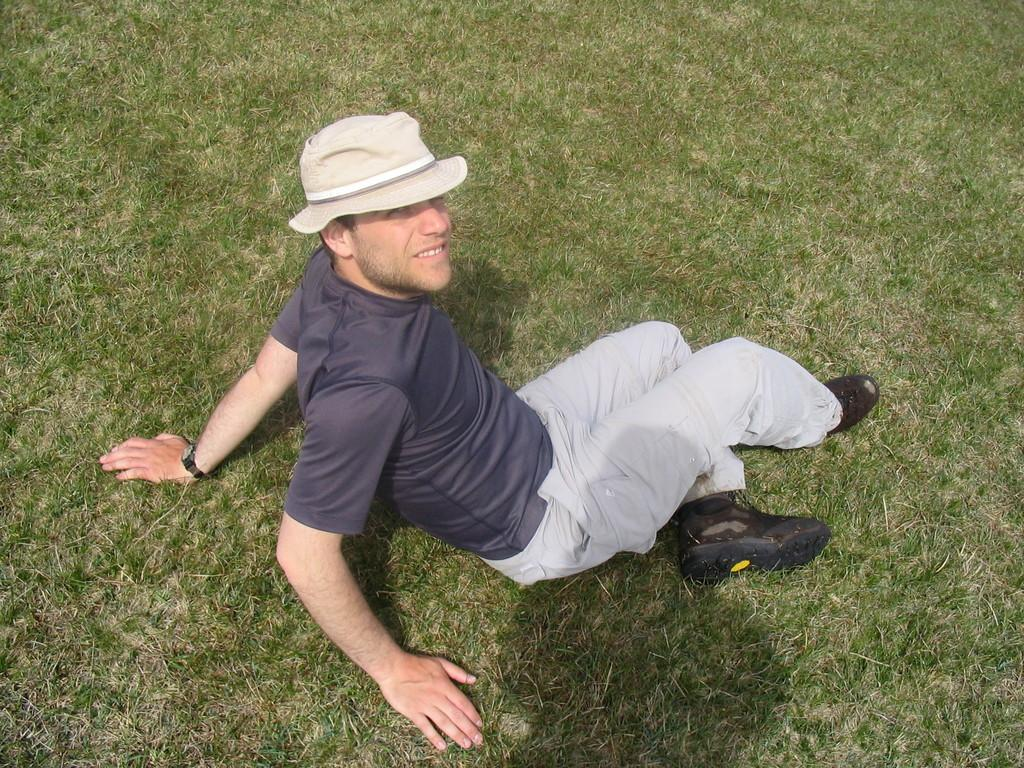Who is present in the image? There is a man in the image. What is the man doing in the image? The man is sitting on the grass. What type of tiger can be seen in the image? There is no tiger present in the image; it only features a man sitting on the grass. 